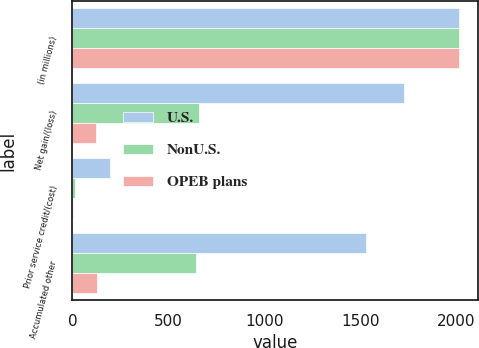Convert chart to OTSL. <chart><loc_0><loc_0><loc_500><loc_500><stacked_bar_chart><ecel><fcel>(in millions)<fcel>Net gain/(loss)<fcel>Prior service credit/(cost)<fcel>Accumulated other<nl><fcel>U.S.<fcel>2013<fcel>1726<fcel>196<fcel>1530<nl><fcel>NonU.S.<fcel>2013<fcel>658<fcel>14<fcel>644<nl><fcel>OPEB plans<fcel>2013<fcel>125<fcel>1<fcel>126<nl></chart> 